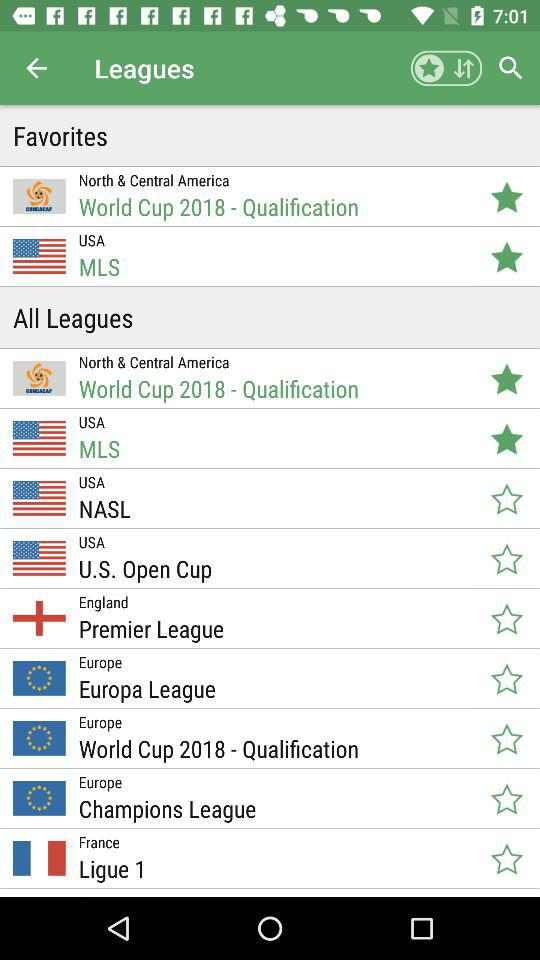What is the location of the NASL league? The location of the NASL league is the USA. 